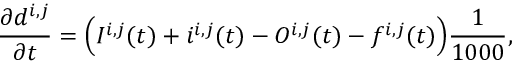Convert formula to latex. <formula><loc_0><loc_0><loc_500><loc_500>\frac { \partial d ^ { i , j } } { \partial t } = \left ( I ^ { i , j } ( t ) + i ^ { i , j } ( t ) - O ^ { i , j } ( t ) - f ^ { i , j } ( t ) \right ) \frac { 1 } { 1 0 0 0 } ,</formula> 